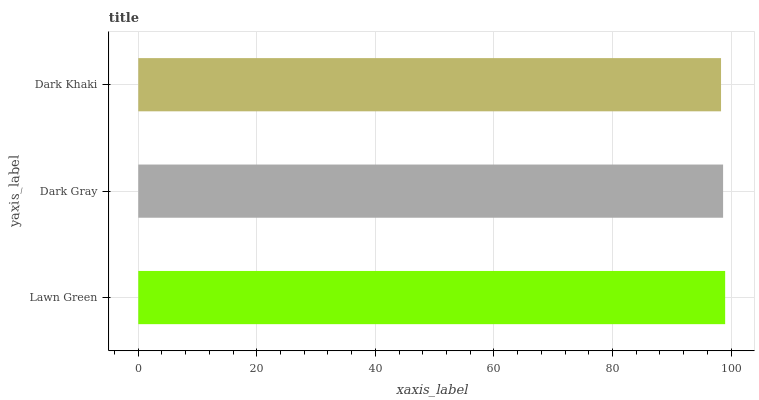Is Dark Khaki the minimum?
Answer yes or no. Yes. Is Lawn Green the maximum?
Answer yes or no. Yes. Is Dark Gray the minimum?
Answer yes or no. No. Is Dark Gray the maximum?
Answer yes or no. No. Is Lawn Green greater than Dark Gray?
Answer yes or no. Yes. Is Dark Gray less than Lawn Green?
Answer yes or no. Yes. Is Dark Gray greater than Lawn Green?
Answer yes or no. No. Is Lawn Green less than Dark Gray?
Answer yes or no. No. Is Dark Gray the high median?
Answer yes or no. Yes. Is Dark Gray the low median?
Answer yes or no. Yes. Is Lawn Green the high median?
Answer yes or no. No. Is Lawn Green the low median?
Answer yes or no. No. 